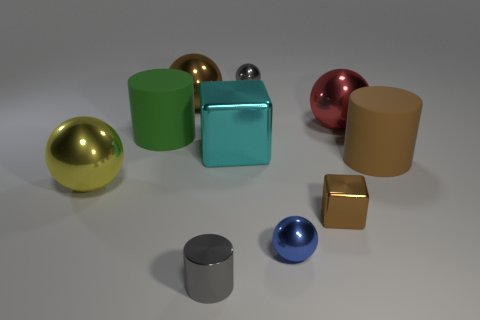There is a matte cylinder to the left of the large brown cylinder; what size is it? The matte cylinder on the left of the large brown cylinder appears to be medium-sized relative to the other objects in the image. It's smaller than the brown cylinder but larger than the small blue sphere near the center of the image. 